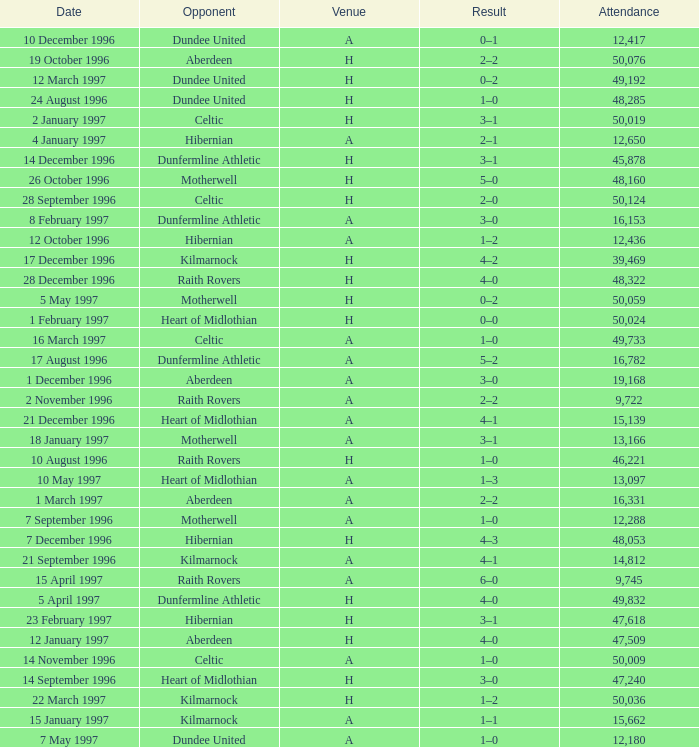When did venue A have an attendance larger than 48,053, and a result of 1–0? 14 November 1996, 16 March 1997. 